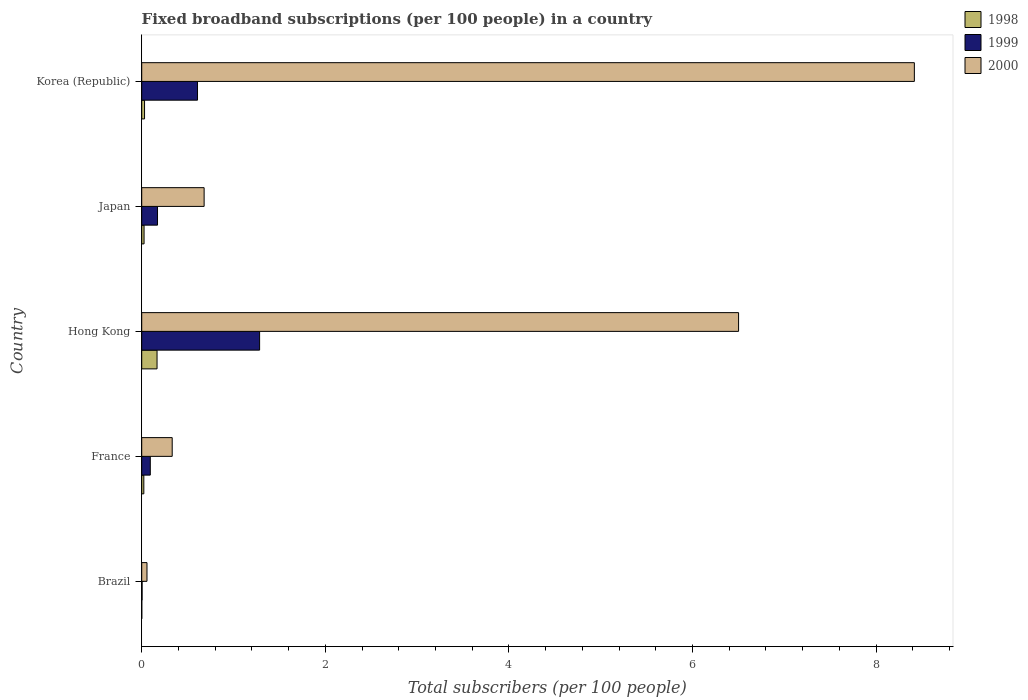How many different coloured bars are there?
Make the answer very short. 3. How many groups of bars are there?
Your response must be concise. 5. Are the number of bars per tick equal to the number of legend labels?
Your answer should be compact. Yes. How many bars are there on the 5th tick from the bottom?
Your response must be concise. 3. What is the number of broadband subscriptions in 1999 in Japan?
Give a very brief answer. 0.17. Across all countries, what is the maximum number of broadband subscriptions in 2000?
Keep it short and to the point. 8.42. Across all countries, what is the minimum number of broadband subscriptions in 1999?
Your answer should be very brief. 0. In which country was the number of broadband subscriptions in 1998 maximum?
Offer a very short reply. Hong Kong. In which country was the number of broadband subscriptions in 1999 minimum?
Offer a terse response. Brazil. What is the total number of broadband subscriptions in 2000 in the graph?
Your answer should be very brief. 15.99. What is the difference between the number of broadband subscriptions in 2000 in Japan and that in Korea (Republic)?
Your answer should be compact. -7.74. What is the difference between the number of broadband subscriptions in 1998 in Hong Kong and the number of broadband subscriptions in 2000 in Korea (Republic)?
Offer a very short reply. -8.25. What is the average number of broadband subscriptions in 1999 per country?
Your answer should be very brief. 0.43. What is the difference between the number of broadband subscriptions in 2000 and number of broadband subscriptions in 1999 in Hong Kong?
Offer a very short reply. 5.22. What is the ratio of the number of broadband subscriptions in 1998 in France to that in Japan?
Your response must be concise. 0.9. Is the number of broadband subscriptions in 1999 in Brazil less than that in Japan?
Your response must be concise. Yes. Is the difference between the number of broadband subscriptions in 2000 in France and Korea (Republic) greater than the difference between the number of broadband subscriptions in 1999 in France and Korea (Republic)?
Ensure brevity in your answer.  No. What is the difference between the highest and the second highest number of broadband subscriptions in 1999?
Offer a very short reply. 0.68. What is the difference between the highest and the lowest number of broadband subscriptions in 1998?
Offer a very short reply. 0.17. In how many countries, is the number of broadband subscriptions in 2000 greater than the average number of broadband subscriptions in 2000 taken over all countries?
Make the answer very short. 2. Is the sum of the number of broadband subscriptions in 2000 in Brazil and France greater than the maximum number of broadband subscriptions in 1999 across all countries?
Provide a short and direct response. No. How many bars are there?
Ensure brevity in your answer.  15. Does the graph contain any zero values?
Ensure brevity in your answer.  No. How many legend labels are there?
Your answer should be very brief. 3. What is the title of the graph?
Provide a succinct answer. Fixed broadband subscriptions (per 100 people) in a country. What is the label or title of the X-axis?
Your answer should be compact. Total subscribers (per 100 people). What is the label or title of the Y-axis?
Provide a short and direct response. Country. What is the Total subscribers (per 100 people) of 1998 in Brazil?
Your response must be concise. 0. What is the Total subscribers (per 100 people) of 1999 in Brazil?
Provide a short and direct response. 0. What is the Total subscribers (per 100 people) in 2000 in Brazil?
Your answer should be compact. 0.06. What is the Total subscribers (per 100 people) of 1998 in France?
Provide a short and direct response. 0.02. What is the Total subscribers (per 100 people) of 1999 in France?
Ensure brevity in your answer.  0.09. What is the Total subscribers (per 100 people) in 2000 in France?
Your response must be concise. 0.33. What is the Total subscribers (per 100 people) of 1998 in Hong Kong?
Provide a succinct answer. 0.17. What is the Total subscribers (per 100 people) in 1999 in Hong Kong?
Provide a short and direct response. 1.28. What is the Total subscribers (per 100 people) of 2000 in Hong Kong?
Offer a very short reply. 6.5. What is the Total subscribers (per 100 people) in 1998 in Japan?
Provide a succinct answer. 0.03. What is the Total subscribers (per 100 people) of 1999 in Japan?
Provide a succinct answer. 0.17. What is the Total subscribers (per 100 people) of 2000 in Japan?
Give a very brief answer. 0.68. What is the Total subscribers (per 100 people) of 1998 in Korea (Republic)?
Offer a terse response. 0.03. What is the Total subscribers (per 100 people) of 1999 in Korea (Republic)?
Keep it short and to the point. 0.61. What is the Total subscribers (per 100 people) of 2000 in Korea (Republic)?
Offer a very short reply. 8.42. Across all countries, what is the maximum Total subscribers (per 100 people) in 1998?
Keep it short and to the point. 0.17. Across all countries, what is the maximum Total subscribers (per 100 people) in 1999?
Offer a very short reply. 1.28. Across all countries, what is the maximum Total subscribers (per 100 people) in 2000?
Provide a succinct answer. 8.42. Across all countries, what is the minimum Total subscribers (per 100 people) of 1998?
Keep it short and to the point. 0. Across all countries, what is the minimum Total subscribers (per 100 people) of 1999?
Your answer should be compact. 0. Across all countries, what is the minimum Total subscribers (per 100 people) of 2000?
Keep it short and to the point. 0.06. What is the total Total subscribers (per 100 people) of 1998 in the graph?
Offer a terse response. 0.25. What is the total Total subscribers (per 100 people) of 1999 in the graph?
Your response must be concise. 2.16. What is the total Total subscribers (per 100 people) of 2000 in the graph?
Keep it short and to the point. 15.99. What is the difference between the Total subscribers (per 100 people) of 1998 in Brazil and that in France?
Provide a succinct answer. -0.02. What is the difference between the Total subscribers (per 100 people) of 1999 in Brazil and that in France?
Your response must be concise. -0.09. What is the difference between the Total subscribers (per 100 people) in 2000 in Brazil and that in France?
Ensure brevity in your answer.  -0.27. What is the difference between the Total subscribers (per 100 people) in 1998 in Brazil and that in Hong Kong?
Your response must be concise. -0.17. What is the difference between the Total subscribers (per 100 people) of 1999 in Brazil and that in Hong Kong?
Make the answer very short. -1.28. What is the difference between the Total subscribers (per 100 people) of 2000 in Brazil and that in Hong Kong?
Offer a terse response. -6.45. What is the difference between the Total subscribers (per 100 people) of 1998 in Brazil and that in Japan?
Provide a succinct answer. -0.03. What is the difference between the Total subscribers (per 100 people) of 1999 in Brazil and that in Japan?
Your answer should be very brief. -0.17. What is the difference between the Total subscribers (per 100 people) in 2000 in Brazil and that in Japan?
Make the answer very short. -0.62. What is the difference between the Total subscribers (per 100 people) of 1998 in Brazil and that in Korea (Republic)?
Provide a succinct answer. -0.03. What is the difference between the Total subscribers (per 100 people) of 1999 in Brazil and that in Korea (Republic)?
Make the answer very short. -0.6. What is the difference between the Total subscribers (per 100 people) of 2000 in Brazil and that in Korea (Republic)?
Offer a terse response. -8.36. What is the difference between the Total subscribers (per 100 people) in 1998 in France and that in Hong Kong?
Your answer should be compact. -0.14. What is the difference between the Total subscribers (per 100 people) in 1999 in France and that in Hong Kong?
Provide a short and direct response. -1.19. What is the difference between the Total subscribers (per 100 people) of 2000 in France and that in Hong Kong?
Give a very brief answer. -6.17. What is the difference between the Total subscribers (per 100 people) in 1998 in France and that in Japan?
Provide a short and direct response. -0. What is the difference between the Total subscribers (per 100 people) in 1999 in France and that in Japan?
Provide a succinct answer. -0.08. What is the difference between the Total subscribers (per 100 people) of 2000 in France and that in Japan?
Your answer should be compact. -0.35. What is the difference between the Total subscribers (per 100 people) of 1998 in France and that in Korea (Republic)?
Keep it short and to the point. -0.01. What is the difference between the Total subscribers (per 100 people) in 1999 in France and that in Korea (Republic)?
Your answer should be compact. -0.51. What is the difference between the Total subscribers (per 100 people) of 2000 in France and that in Korea (Republic)?
Make the answer very short. -8.09. What is the difference between the Total subscribers (per 100 people) in 1998 in Hong Kong and that in Japan?
Provide a succinct answer. 0.14. What is the difference between the Total subscribers (per 100 people) in 1999 in Hong Kong and that in Japan?
Offer a terse response. 1.11. What is the difference between the Total subscribers (per 100 people) in 2000 in Hong Kong and that in Japan?
Make the answer very short. 5.82. What is the difference between the Total subscribers (per 100 people) in 1998 in Hong Kong and that in Korea (Republic)?
Offer a terse response. 0.14. What is the difference between the Total subscribers (per 100 people) of 1999 in Hong Kong and that in Korea (Republic)?
Keep it short and to the point. 0.68. What is the difference between the Total subscribers (per 100 people) in 2000 in Hong Kong and that in Korea (Republic)?
Ensure brevity in your answer.  -1.91. What is the difference between the Total subscribers (per 100 people) in 1998 in Japan and that in Korea (Republic)?
Offer a terse response. -0.01. What is the difference between the Total subscribers (per 100 people) of 1999 in Japan and that in Korea (Republic)?
Make the answer very short. -0.44. What is the difference between the Total subscribers (per 100 people) in 2000 in Japan and that in Korea (Republic)?
Offer a terse response. -7.74. What is the difference between the Total subscribers (per 100 people) in 1998 in Brazil and the Total subscribers (per 100 people) in 1999 in France?
Your answer should be very brief. -0.09. What is the difference between the Total subscribers (per 100 people) in 1998 in Brazil and the Total subscribers (per 100 people) in 2000 in France?
Keep it short and to the point. -0.33. What is the difference between the Total subscribers (per 100 people) in 1999 in Brazil and the Total subscribers (per 100 people) in 2000 in France?
Make the answer very short. -0.33. What is the difference between the Total subscribers (per 100 people) of 1998 in Brazil and the Total subscribers (per 100 people) of 1999 in Hong Kong?
Your answer should be compact. -1.28. What is the difference between the Total subscribers (per 100 people) in 1998 in Brazil and the Total subscribers (per 100 people) in 2000 in Hong Kong?
Your answer should be compact. -6.5. What is the difference between the Total subscribers (per 100 people) in 1999 in Brazil and the Total subscribers (per 100 people) in 2000 in Hong Kong?
Give a very brief answer. -6.5. What is the difference between the Total subscribers (per 100 people) of 1998 in Brazil and the Total subscribers (per 100 people) of 1999 in Japan?
Your answer should be very brief. -0.17. What is the difference between the Total subscribers (per 100 people) of 1998 in Brazil and the Total subscribers (per 100 people) of 2000 in Japan?
Ensure brevity in your answer.  -0.68. What is the difference between the Total subscribers (per 100 people) in 1999 in Brazil and the Total subscribers (per 100 people) in 2000 in Japan?
Give a very brief answer. -0.68. What is the difference between the Total subscribers (per 100 people) in 1998 in Brazil and the Total subscribers (per 100 people) in 1999 in Korea (Republic)?
Provide a short and direct response. -0.61. What is the difference between the Total subscribers (per 100 people) in 1998 in Brazil and the Total subscribers (per 100 people) in 2000 in Korea (Republic)?
Ensure brevity in your answer.  -8.42. What is the difference between the Total subscribers (per 100 people) of 1999 in Brazil and the Total subscribers (per 100 people) of 2000 in Korea (Republic)?
Offer a terse response. -8.41. What is the difference between the Total subscribers (per 100 people) of 1998 in France and the Total subscribers (per 100 people) of 1999 in Hong Kong?
Offer a terse response. -1.26. What is the difference between the Total subscribers (per 100 people) of 1998 in France and the Total subscribers (per 100 people) of 2000 in Hong Kong?
Your response must be concise. -6.48. What is the difference between the Total subscribers (per 100 people) of 1999 in France and the Total subscribers (per 100 people) of 2000 in Hong Kong?
Provide a succinct answer. -6.41. What is the difference between the Total subscribers (per 100 people) in 1998 in France and the Total subscribers (per 100 people) in 1999 in Japan?
Make the answer very short. -0.15. What is the difference between the Total subscribers (per 100 people) of 1998 in France and the Total subscribers (per 100 people) of 2000 in Japan?
Your response must be concise. -0.66. What is the difference between the Total subscribers (per 100 people) of 1999 in France and the Total subscribers (per 100 people) of 2000 in Japan?
Offer a very short reply. -0.59. What is the difference between the Total subscribers (per 100 people) of 1998 in France and the Total subscribers (per 100 people) of 1999 in Korea (Republic)?
Provide a short and direct response. -0.58. What is the difference between the Total subscribers (per 100 people) of 1998 in France and the Total subscribers (per 100 people) of 2000 in Korea (Republic)?
Your answer should be very brief. -8.39. What is the difference between the Total subscribers (per 100 people) in 1999 in France and the Total subscribers (per 100 people) in 2000 in Korea (Republic)?
Offer a terse response. -8.32. What is the difference between the Total subscribers (per 100 people) in 1998 in Hong Kong and the Total subscribers (per 100 people) in 1999 in Japan?
Give a very brief answer. -0.01. What is the difference between the Total subscribers (per 100 people) in 1998 in Hong Kong and the Total subscribers (per 100 people) in 2000 in Japan?
Offer a very short reply. -0.51. What is the difference between the Total subscribers (per 100 people) in 1999 in Hong Kong and the Total subscribers (per 100 people) in 2000 in Japan?
Make the answer very short. 0.6. What is the difference between the Total subscribers (per 100 people) of 1998 in Hong Kong and the Total subscribers (per 100 people) of 1999 in Korea (Republic)?
Your answer should be very brief. -0.44. What is the difference between the Total subscribers (per 100 people) in 1998 in Hong Kong and the Total subscribers (per 100 people) in 2000 in Korea (Republic)?
Provide a succinct answer. -8.25. What is the difference between the Total subscribers (per 100 people) of 1999 in Hong Kong and the Total subscribers (per 100 people) of 2000 in Korea (Republic)?
Offer a terse response. -7.13. What is the difference between the Total subscribers (per 100 people) in 1998 in Japan and the Total subscribers (per 100 people) in 1999 in Korea (Republic)?
Your answer should be compact. -0.58. What is the difference between the Total subscribers (per 100 people) in 1998 in Japan and the Total subscribers (per 100 people) in 2000 in Korea (Republic)?
Make the answer very short. -8.39. What is the difference between the Total subscribers (per 100 people) in 1999 in Japan and the Total subscribers (per 100 people) in 2000 in Korea (Republic)?
Your response must be concise. -8.25. What is the average Total subscribers (per 100 people) of 1998 per country?
Your answer should be compact. 0.05. What is the average Total subscribers (per 100 people) of 1999 per country?
Your answer should be compact. 0.43. What is the average Total subscribers (per 100 people) of 2000 per country?
Your response must be concise. 3.2. What is the difference between the Total subscribers (per 100 people) of 1998 and Total subscribers (per 100 people) of 1999 in Brazil?
Give a very brief answer. -0. What is the difference between the Total subscribers (per 100 people) in 1998 and Total subscribers (per 100 people) in 2000 in Brazil?
Provide a succinct answer. -0.06. What is the difference between the Total subscribers (per 100 people) of 1999 and Total subscribers (per 100 people) of 2000 in Brazil?
Your response must be concise. -0.05. What is the difference between the Total subscribers (per 100 people) of 1998 and Total subscribers (per 100 people) of 1999 in France?
Your response must be concise. -0.07. What is the difference between the Total subscribers (per 100 people) in 1998 and Total subscribers (per 100 people) in 2000 in France?
Your answer should be very brief. -0.31. What is the difference between the Total subscribers (per 100 people) in 1999 and Total subscribers (per 100 people) in 2000 in France?
Ensure brevity in your answer.  -0.24. What is the difference between the Total subscribers (per 100 people) of 1998 and Total subscribers (per 100 people) of 1999 in Hong Kong?
Ensure brevity in your answer.  -1.12. What is the difference between the Total subscribers (per 100 people) of 1998 and Total subscribers (per 100 people) of 2000 in Hong Kong?
Your response must be concise. -6.34. What is the difference between the Total subscribers (per 100 people) of 1999 and Total subscribers (per 100 people) of 2000 in Hong Kong?
Provide a short and direct response. -5.22. What is the difference between the Total subscribers (per 100 people) of 1998 and Total subscribers (per 100 people) of 1999 in Japan?
Your answer should be compact. -0.15. What is the difference between the Total subscribers (per 100 people) of 1998 and Total subscribers (per 100 people) of 2000 in Japan?
Make the answer very short. -0.65. What is the difference between the Total subscribers (per 100 people) in 1999 and Total subscribers (per 100 people) in 2000 in Japan?
Your response must be concise. -0.51. What is the difference between the Total subscribers (per 100 people) in 1998 and Total subscribers (per 100 people) in 1999 in Korea (Republic)?
Your answer should be very brief. -0.58. What is the difference between the Total subscribers (per 100 people) in 1998 and Total subscribers (per 100 people) in 2000 in Korea (Republic)?
Make the answer very short. -8.39. What is the difference between the Total subscribers (per 100 people) in 1999 and Total subscribers (per 100 people) in 2000 in Korea (Republic)?
Offer a very short reply. -7.81. What is the ratio of the Total subscribers (per 100 people) of 1998 in Brazil to that in France?
Your response must be concise. 0.03. What is the ratio of the Total subscribers (per 100 people) of 1999 in Brazil to that in France?
Ensure brevity in your answer.  0.04. What is the ratio of the Total subscribers (per 100 people) in 2000 in Brazil to that in France?
Keep it short and to the point. 0.17. What is the ratio of the Total subscribers (per 100 people) of 1998 in Brazil to that in Hong Kong?
Make the answer very short. 0. What is the ratio of the Total subscribers (per 100 people) in 1999 in Brazil to that in Hong Kong?
Provide a succinct answer. 0. What is the ratio of the Total subscribers (per 100 people) of 2000 in Brazil to that in Hong Kong?
Offer a terse response. 0.01. What is the ratio of the Total subscribers (per 100 people) of 1998 in Brazil to that in Japan?
Your answer should be compact. 0.02. What is the ratio of the Total subscribers (per 100 people) of 1999 in Brazil to that in Japan?
Keep it short and to the point. 0.02. What is the ratio of the Total subscribers (per 100 people) of 2000 in Brazil to that in Japan?
Make the answer very short. 0.08. What is the ratio of the Total subscribers (per 100 people) in 1998 in Brazil to that in Korea (Republic)?
Your answer should be very brief. 0.02. What is the ratio of the Total subscribers (per 100 people) in 1999 in Brazil to that in Korea (Republic)?
Make the answer very short. 0.01. What is the ratio of the Total subscribers (per 100 people) in 2000 in Brazil to that in Korea (Republic)?
Your answer should be very brief. 0.01. What is the ratio of the Total subscribers (per 100 people) in 1998 in France to that in Hong Kong?
Offer a very short reply. 0.14. What is the ratio of the Total subscribers (per 100 people) in 1999 in France to that in Hong Kong?
Keep it short and to the point. 0.07. What is the ratio of the Total subscribers (per 100 people) in 2000 in France to that in Hong Kong?
Your answer should be very brief. 0.05. What is the ratio of the Total subscribers (per 100 people) of 1998 in France to that in Japan?
Keep it short and to the point. 0.9. What is the ratio of the Total subscribers (per 100 people) of 1999 in France to that in Japan?
Offer a very short reply. 0.54. What is the ratio of the Total subscribers (per 100 people) of 2000 in France to that in Japan?
Your response must be concise. 0.49. What is the ratio of the Total subscribers (per 100 people) of 1998 in France to that in Korea (Republic)?
Make the answer very short. 0.75. What is the ratio of the Total subscribers (per 100 people) of 1999 in France to that in Korea (Republic)?
Ensure brevity in your answer.  0.15. What is the ratio of the Total subscribers (per 100 people) in 2000 in France to that in Korea (Republic)?
Offer a terse response. 0.04. What is the ratio of the Total subscribers (per 100 people) in 1998 in Hong Kong to that in Japan?
Your answer should be compact. 6.53. What is the ratio of the Total subscribers (per 100 people) in 1999 in Hong Kong to that in Japan?
Your answer should be compact. 7.46. What is the ratio of the Total subscribers (per 100 people) in 2000 in Hong Kong to that in Japan?
Keep it short and to the point. 9.56. What is the ratio of the Total subscribers (per 100 people) of 1998 in Hong Kong to that in Korea (Republic)?
Keep it short and to the point. 5.42. What is the ratio of the Total subscribers (per 100 people) of 1999 in Hong Kong to that in Korea (Republic)?
Offer a terse response. 2.11. What is the ratio of the Total subscribers (per 100 people) in 2000 in Hong Kong to that in Korea (Republic)?
Your answer should be compact. 0.77. What is the ratio of the Total subscribers (per 100 people) of 1998 in Japan to that in Korea (Republic)?
Give a very brief answer. 0.83. What is the ratio of the Total subscribers (per 100 people) of 1999 in Japan to that in Korea (Republic)?
Offer a terse response. 0.28. What is the ratio of the Total subscribers (per 100 people) of 2000 in Japan to that in Korea (Republic)?
Offer a terse response. 0.08. What is the difference between the highest and the second highest Total subscribers (per 100 people) of 1998?
Make the answer very short. 0.14. What is the difference between the highest and the second highest Total subscribers (per 100 people) in 1999?
Keep it short and to the point. 0.68. What is the difference between the highest and the second highest Total subscribers (per 100 people) of 2000?
Provide a short and direct response. 1.91. What is the difference between the highest and the lowest Total subscribers (per 100 people) in 1998?
Keep it short and to the point. 0.17. What is the difference between the highest and the lowest Total subscribers (per 100 people) of 1999?
Ensure brevity in your answer.  1.28. What is the difference between the highest and the lowest Total subscribers (per 100 people) in 2000?
Your answer should be compact. 8.36. 